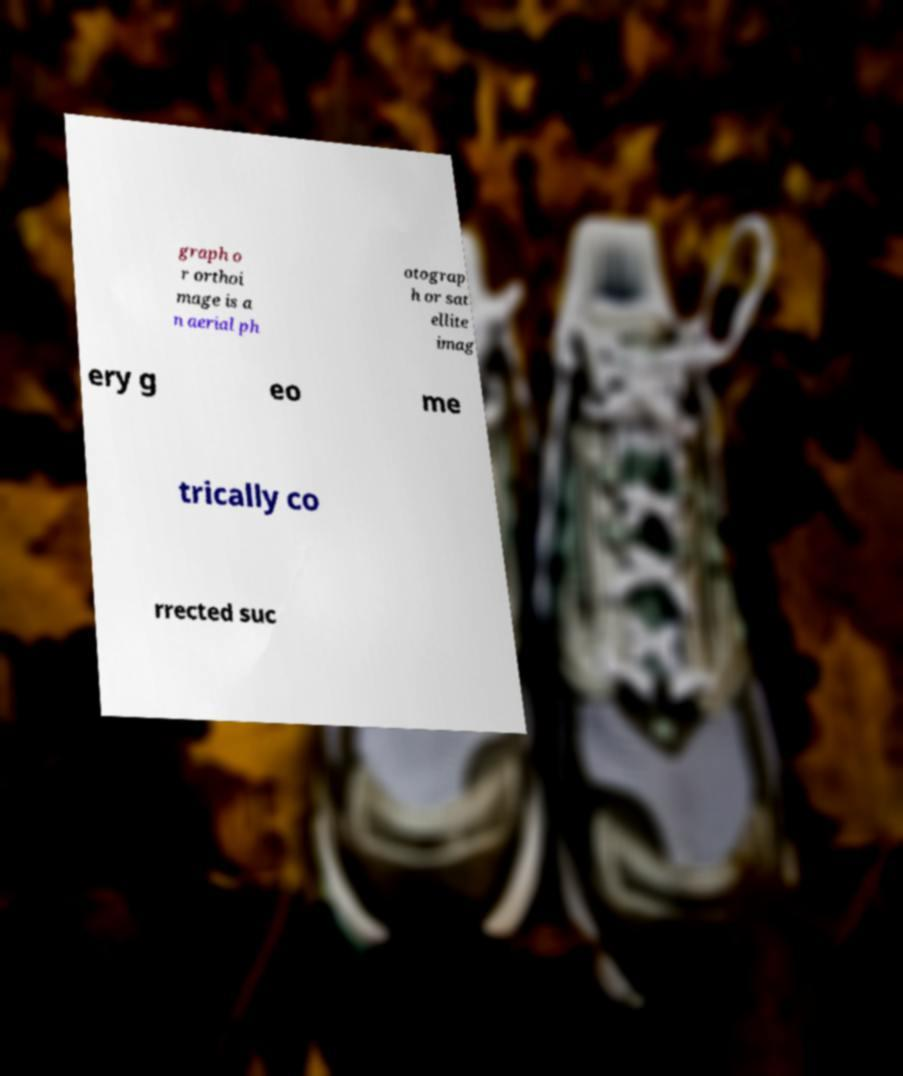I need the written content from this picture converted into text. Can you do that? graph o r orthoi mage is a n aerial ph otograp h or sat ellite imag ery g eo me trically co rrected suc 